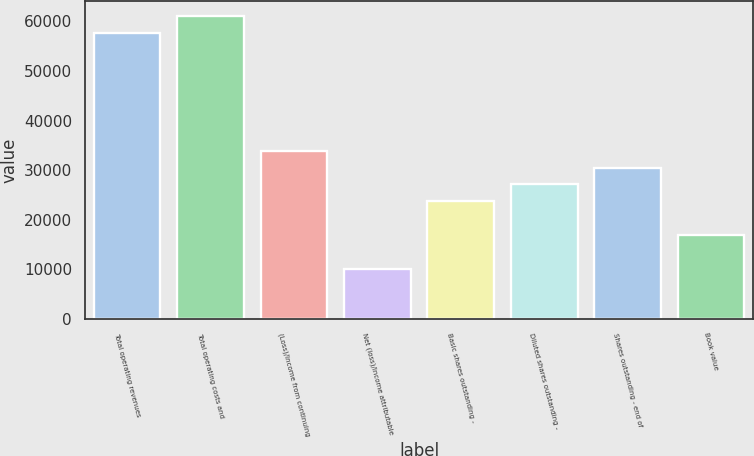Convert chart. <chart><loc_0><loc_0><loc_500><loc_500><bar_chart><fcel>Total operating revenues<fcel>Total operating costs and<fcel>(Loss)/Income from continuing<fcel>Net (loss)/income attributable<fcel>Basic shares outstanding -<fcel>Diluted shares outstanding -<fcel>Shares outstanding - end of<fcel>Book value<nl><fcel>57633.2<fcel>61023.3<fcel>33902<fcel>10170.8<fcel>23731.5<fcel>27121.7<fcel>30511.8<fcel>16951.1<nl></chart> 